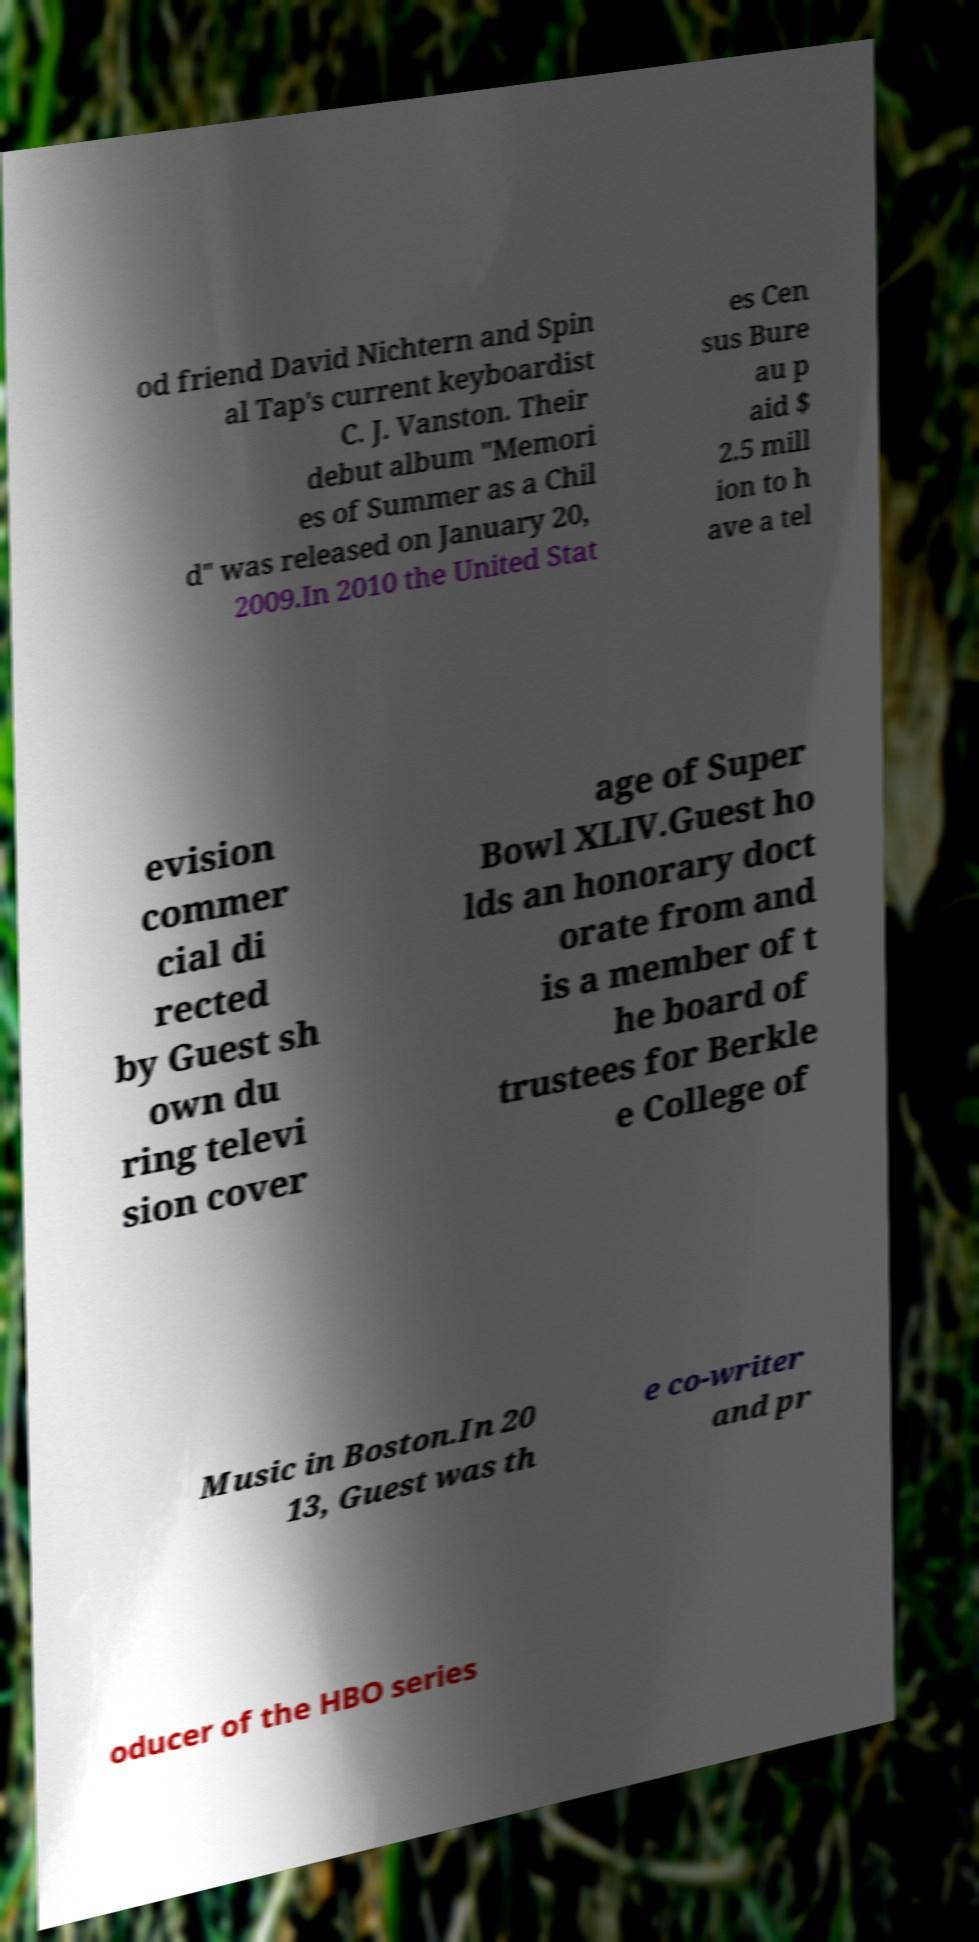I need the written content from this picture converted into text. Can you do that? od friend David Nichtern and Spin al Tap's current keyboardist C. J. Vanston. Their debut album "Memori es of Summer as a Chil d" was released on January 20, 2009.In 2010 the United Stat es Cen sus Bure au p aid $ 2.5 mill ion to h ave a tel evision commer cial di rected by Guest sh own du ring televi sion cover age of Super Bowl XLIV.Guest ho lds an honorary doct orate from and is a member of t he board of trustees for Berkle e College of Music in Boston.In 20 13, Guest was th e co-writer and pr oducer of the HBO series 